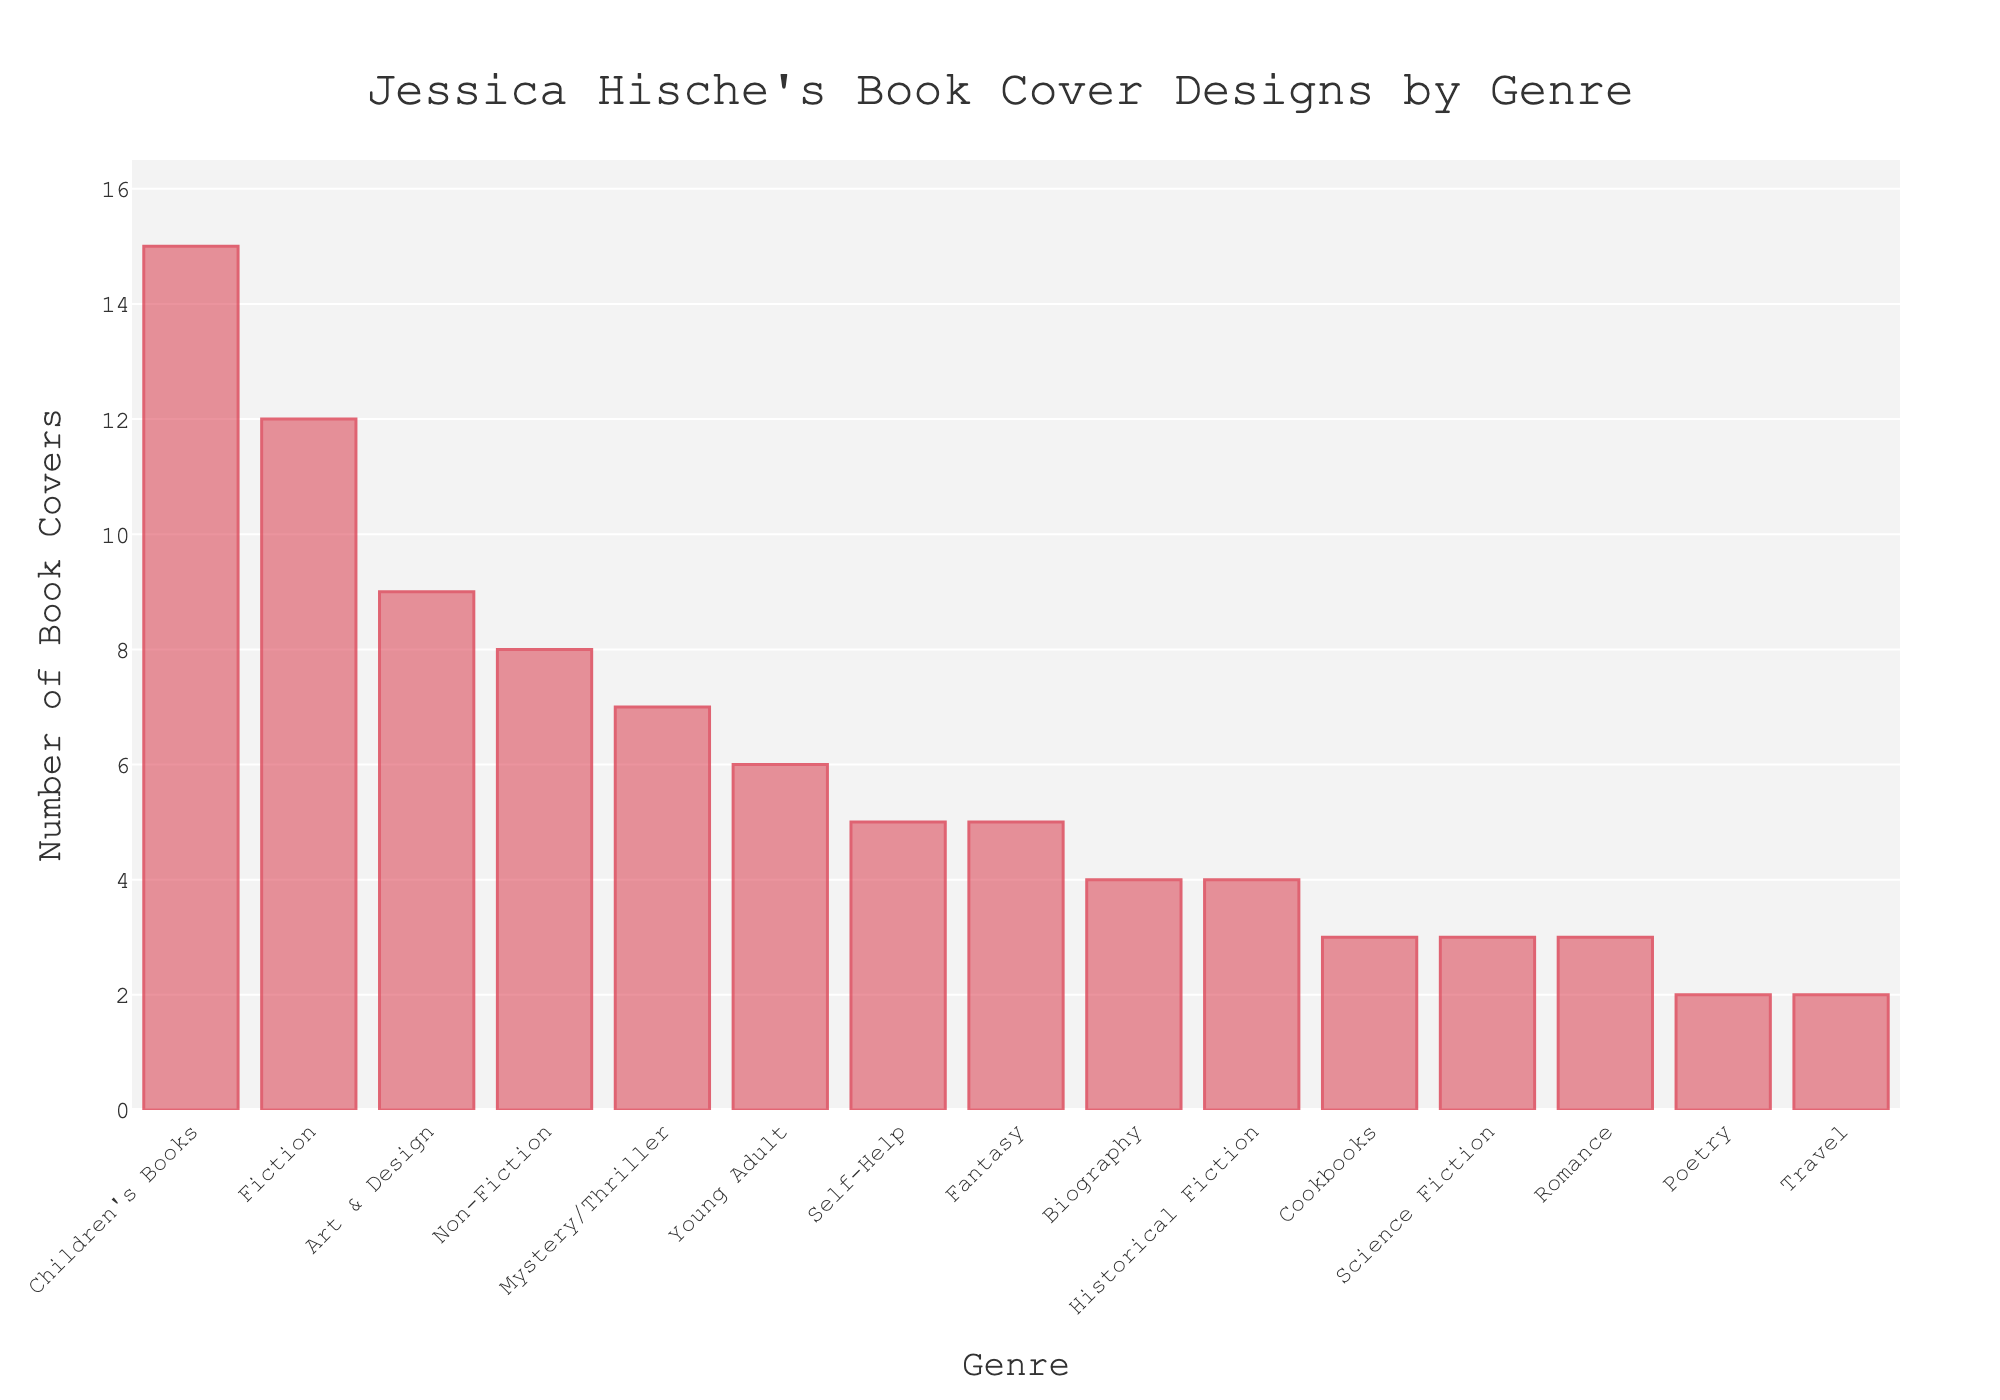Which genre has the highest number of book covers? We look for the bar with the greatest height, which represents the largest value. The highest bar in the chart corresponds to "Children's Books" with 15 covers.
Answer: Children's Books What is the total number of book covers for Fiction, Non-Fiction, and Biography combined? Sum up the values for these genres: Fiction (12), Non-Fiction (8), Biography (4). Thus, 12 + 8 + 4 = 24.
Answer: 24 Between Mystery/Thriller and Romance, which genre has more covers, and by how many? Compare the values for these two genres: Mystery/Thriller (7) and Romance (3). Subtract the smaller value from the larger value to get the difference: 7 - 3 = 4.
Answer: Mystery/Thriller by 4 What is the average number of book covers for the three genres with the least covers? Identify the three genres with the fewest covers: Poetry (2), Travel (2), and Cookbooks (3). Calculate the average: (2 + 2 + 3) / 3 = 7 / 3 ≈ 2.33.
Answer: 2.33 How many genres have more than 6 book covers? Count the bars with heights greater than 6: Fiction (12), Children's Books (15), Non-Fiction (8), Art & Design (9), and Mystery/Thriller (7). There are 5 such genres.
Answer: 5 Which genre has exactly two book covers? Look for the bar corresponding to the number 2. Both "Poetry" and "Travel" have exactly two covers.
Answer: Poetry and Travel What is the ratio of the number of covers in Children's Books to Self-Help? Children's Books has 15 covers and Self-Help has 5 covers. The ratio is 15:5, which simplifies to 3:1.
Answer: 3:1 If we combine the covers for Historical Fiction and Science Fiction, how many covers will there be in total? Add the values for these genres: Historical Fiction (4) + Science Fiction (3) = 7.
Answer: 7 